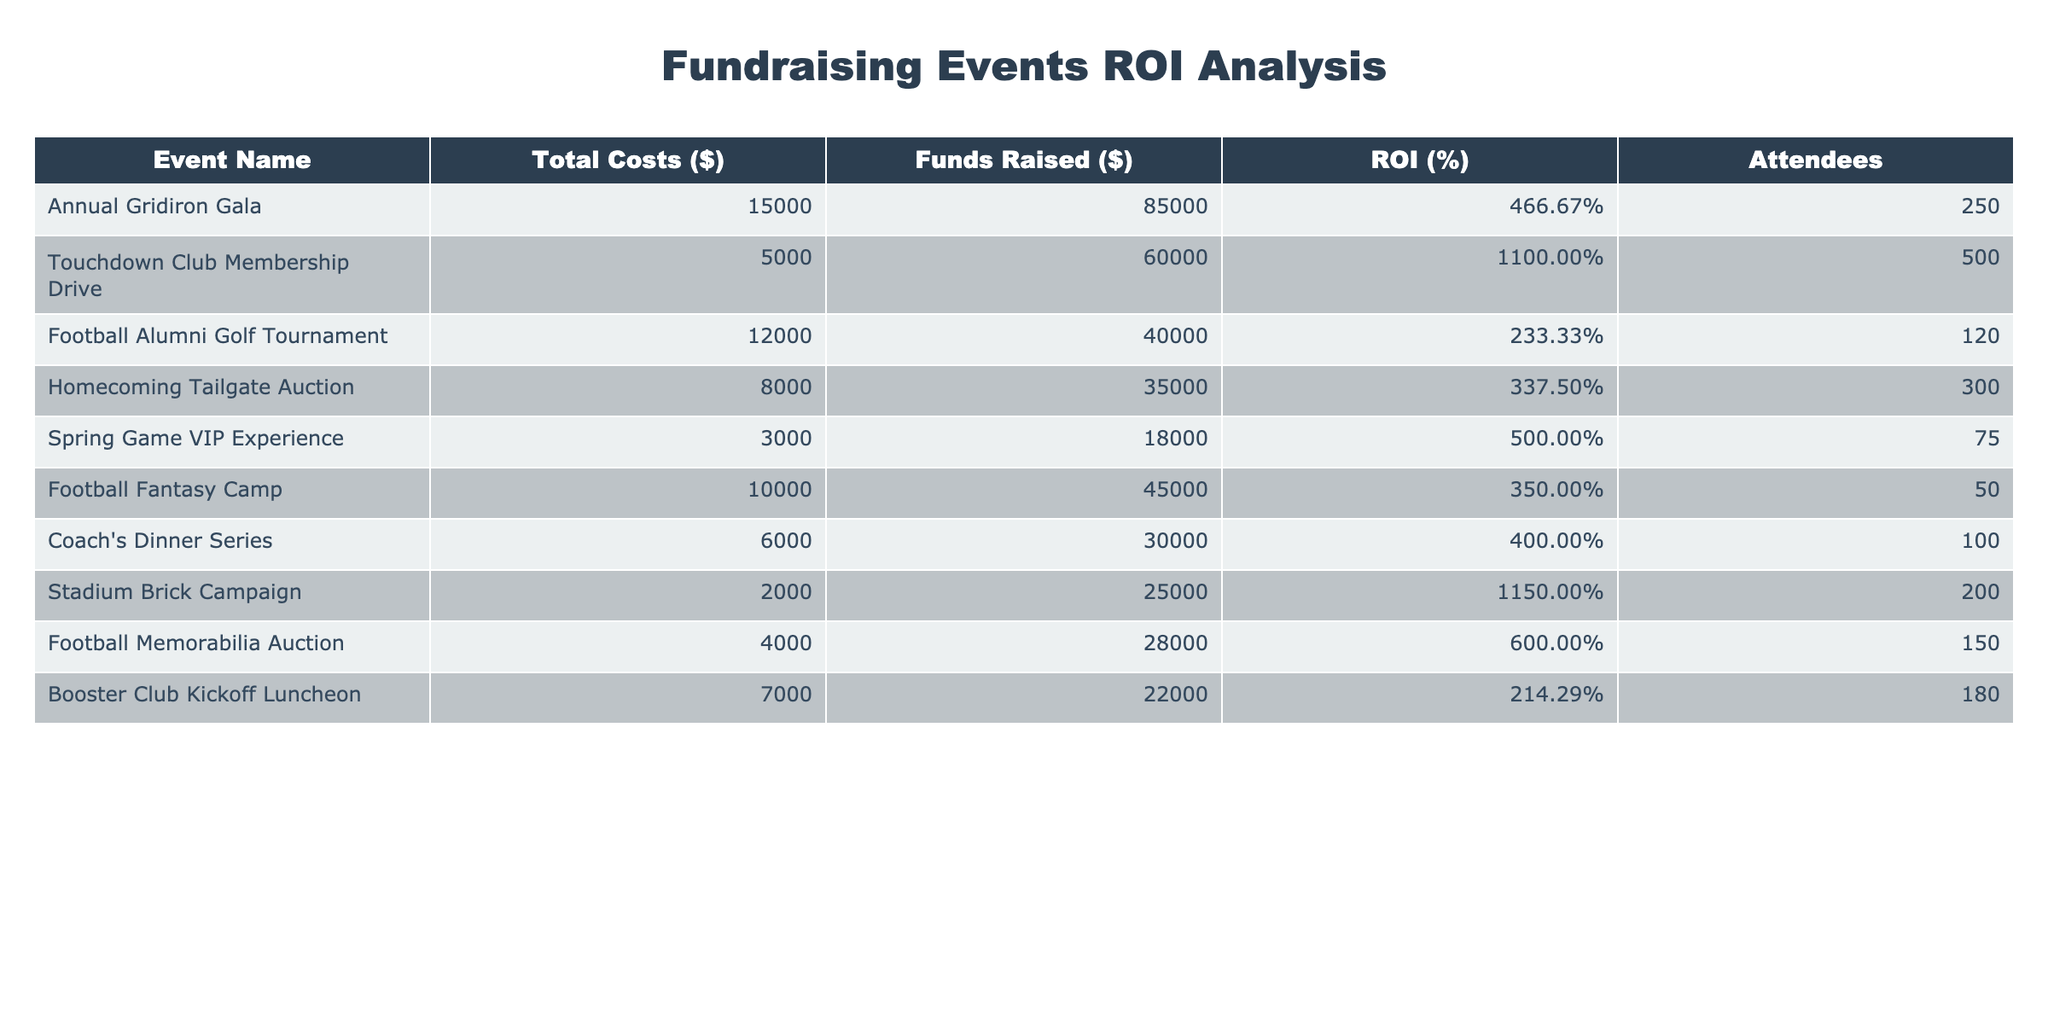What is the ROI for the Touchdown Club Membership Drive? The table lists the ROI for each event, and for the Touchdown Club Membership Drive, it is stated as 1100.00%.
Answer: 1100.00% Which fundraising event had the highest total costs? By reviewing the "Total Costs ($)" column, it is clear that the Annual Gridiron Gala had the highest total costs at $15,000.
Answer: Annual Gridiron Gala What is the average number of attendees across all events? Adding the number of attendees for all events (250 + 500 + 120 + 300 + 75 + 50 + 100 + 200 + 150 + 180) equals 1875. Dividing this by the number of events (10), the average is 187.5.
Answer: 187.5 True or False: The Football Alumni Golf Tournament had a higher ROI than the Homecoming Tailgate Auction. The ROI for the Football Alumni Golf Tournament is 233.33%, while the ROI for the Homecoming Tailgate Auction is 337.50%. Therefore, the statement is False.
Answer: False What is the total amount of funds raised from all events? Adding up the funds raised amounts ($85,000 + $60,000 + $40,000 + $35,000 + $18,000 + $45,000 + $30,000 + $25,000 + $28,000 + $22,000) gives a total of $413,000.
Answer: $413,000 Which event had the least number of attendees? Looking at the "Attendees" column, the Football Fantasy Camp had the least number of attendees with 50 individuals.
Answer: Football Fantasy Camp What is the difference in ROI between the Stadium Brick Campaign and the Football Memorabilia Auction? The ROI for the Stadium Brick Campaign is 1150.00%, and for the Football Memorabilia Auction, it is 600.00%. The difference is 1150.00% - 600.00% = 550.00%.
Answer: 550.00% Which event had the highest funds raised relative to its costs? The ROI metric already provides this insight, but specifically, the Touchdown Club Membership Drive with an ROI of 1100.00% signifies that it had the highest funds raised relative to its costs.
Answer: Touchdown Club Membership Drive How many events had an ROI greater than 400%? By reviewing the ROI percentages listed in the table, the events exceeding 400% are the Touchdown Club Membership Drive, Stadium Brick Campaign, Annual Gridiron Gala, and Coach's Dinner Series, totaling four events.
Answer: 4 If the Spring Game VIP Experience costs doubled, what would its new ROI be based on the funds raised? The current costs are $3,000. If they double, the new costs would be $6,000. With the funds raised being $18,000, the new ROI would be calculated as (Funds Raised - New Costs) / New Costs * 100%, which is (($18,000 - $6,000) / $6,000) * 100% = 200.00%.
Answer: 200.00% 